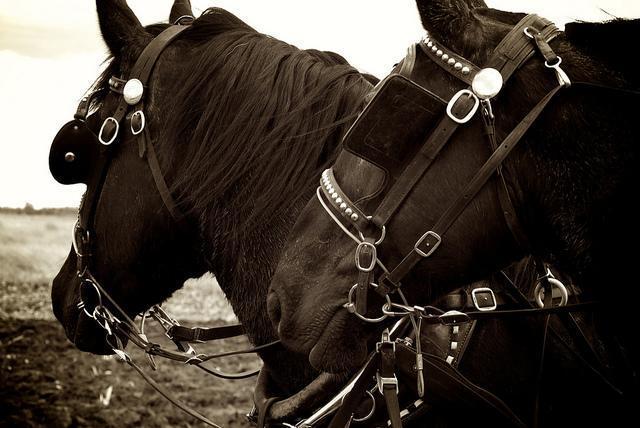How many horses are there?
Give a very brief answer. 2. 